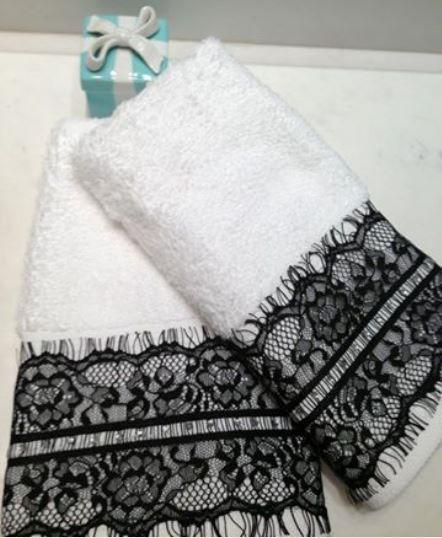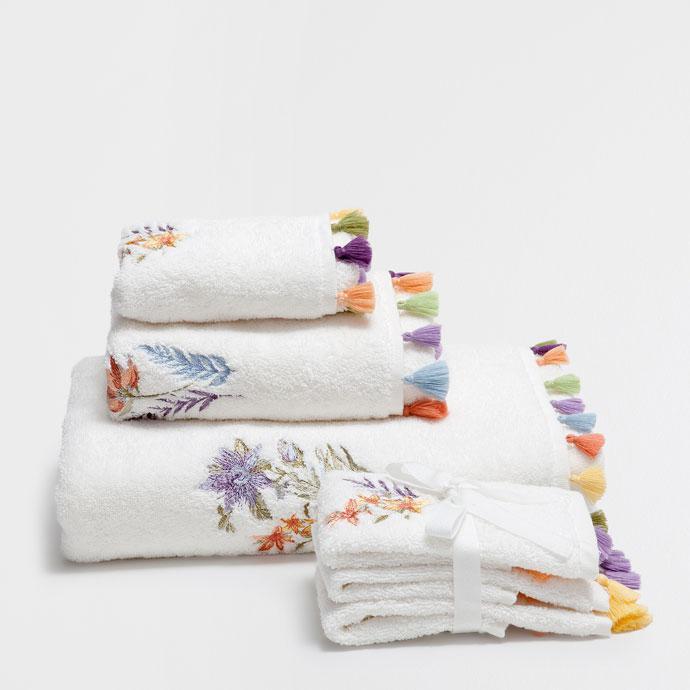The first image is the image on the left, the second image is the image on the right. Considering the images on both sides, is "There is a stack of towels on the right." valid? Answer yes or no. Yes. The first image is the image on the left, the second image is the image on the right. Evaluate the accuracy of this statement regarding the images: "There are at least two very light brown towels with its top half white with S looking vines sewn into it.". Is it true? Answer yes or no. No. 